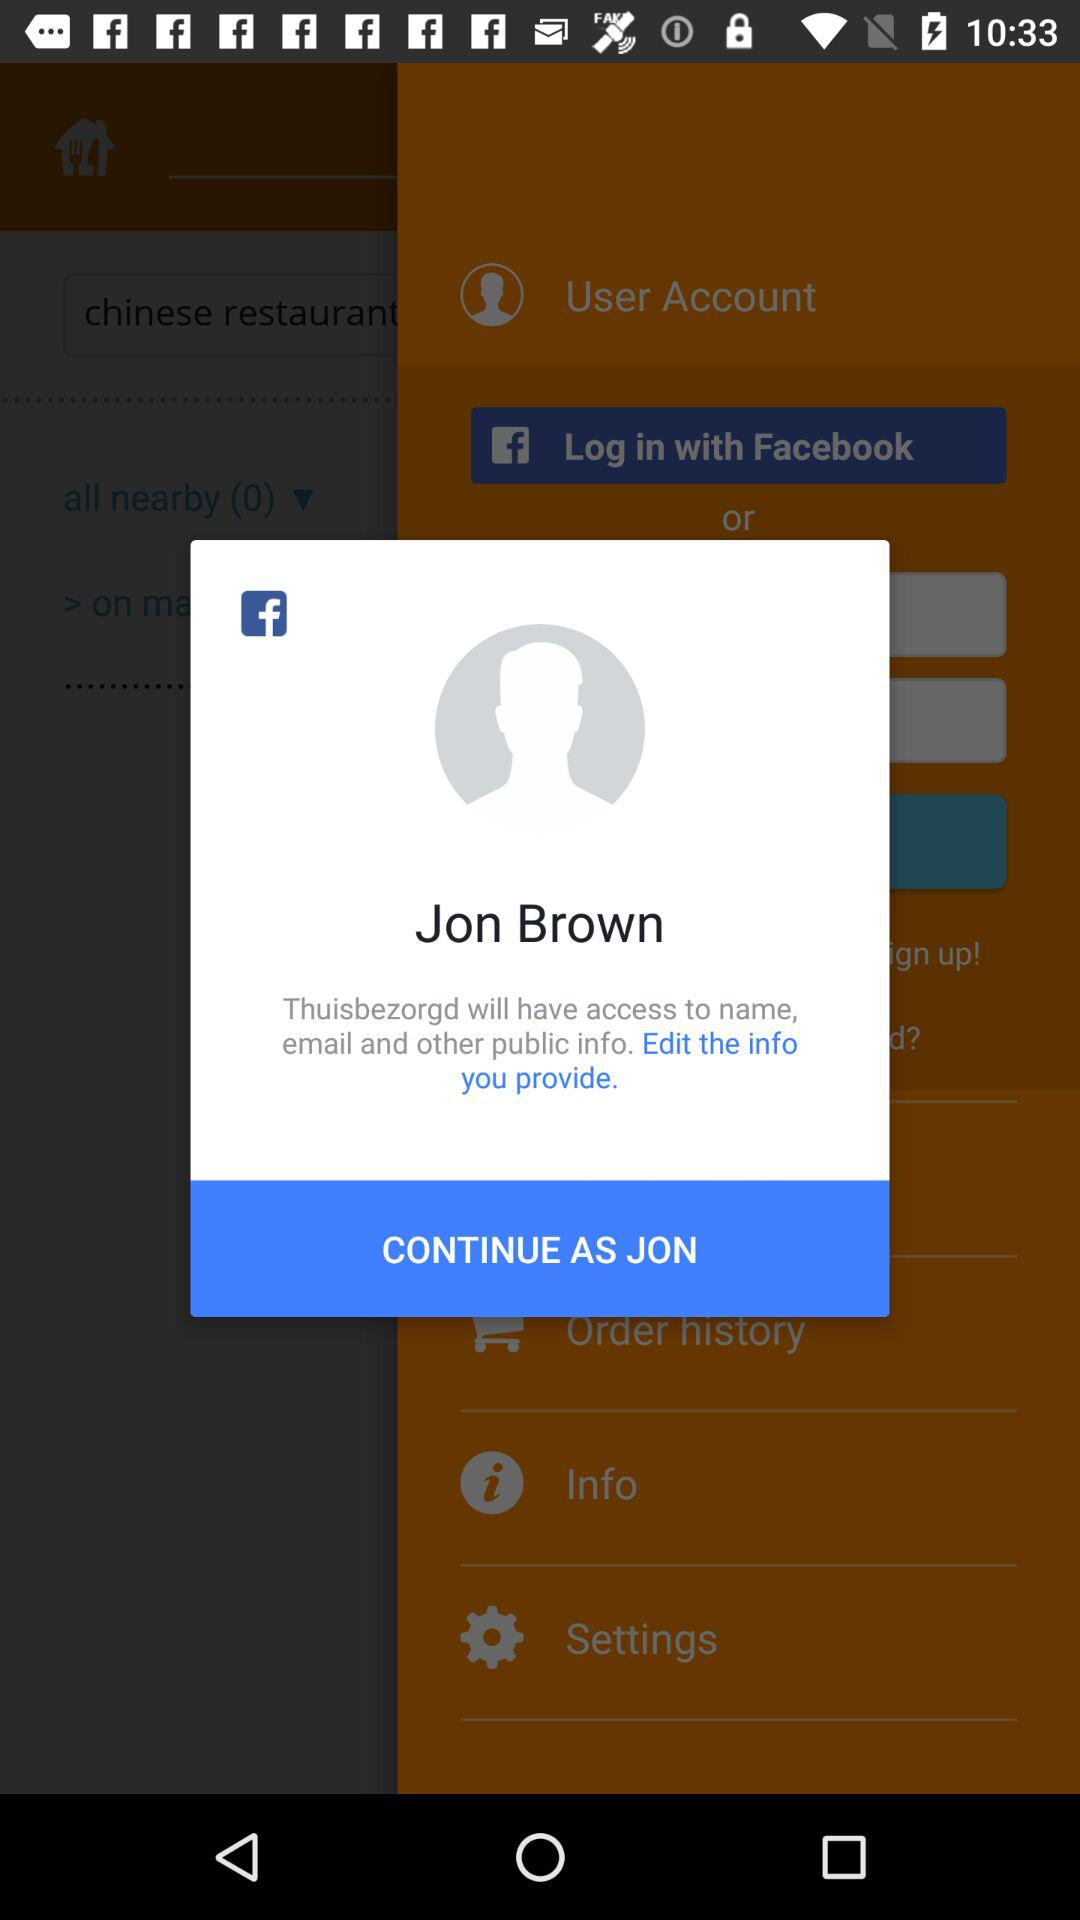What is the name of the user? The name of the user is Jon Brown. 